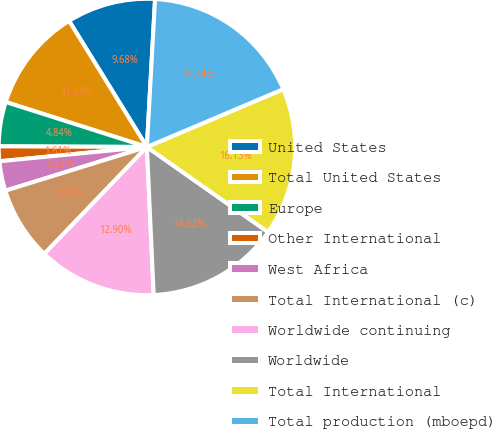Convert chart. <chart><loc_0><loc_0><loc_500><loc_500><pie_chart><fcel>United States<fcel>Total United States<fcel>Europe<fcel>Other International<fcel>West Africa<fcel>Total International (c)<fcel>Worldwide continuing<fcel>Worldwide<fcel>Total International<fcel>Total production (mboepd)<nl><fcel>9.68%<fcel>11.29%<fcel>4.84%<fcel>1.61%<fcel>3.23%<fcel>8.06%<fcel>12.9%<fcel>14.52%<fcel>16.13%<fcel>17.74%<nl></chart> 